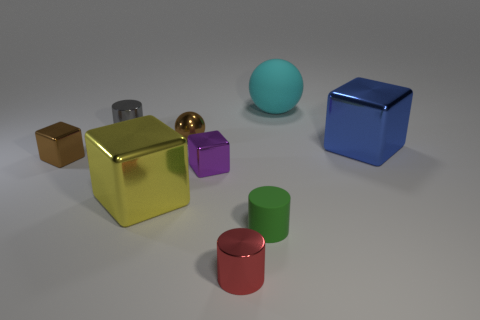Which objects in the picture could be considered reflective, and how can you tell? The objects that appear reflective are the gold cube, the gold sphere, the small purple cube, and the tiny blue metallic cube. This is discernible by the way they interact with light compared to the matte objects, showing highlighted edges and a mirrored effect on their surfaces. Is there anything in the image that indicates a possible light source? Yes, the reflections and shadows on and around the objects suggest a light source above them. Specifically, the positioning and length of the shadows indicate the light source might be somewhat forward of the center of the arrangement, slightly off to the left. 